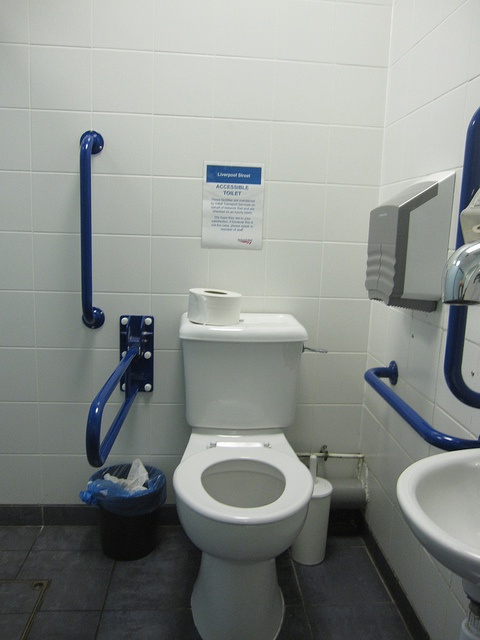Describe the objects in this image and their specific colors. I can see toilet in darkgray, gray, and lightgray tones and sink in darkgray, lightgray, and gray tones in this image. 